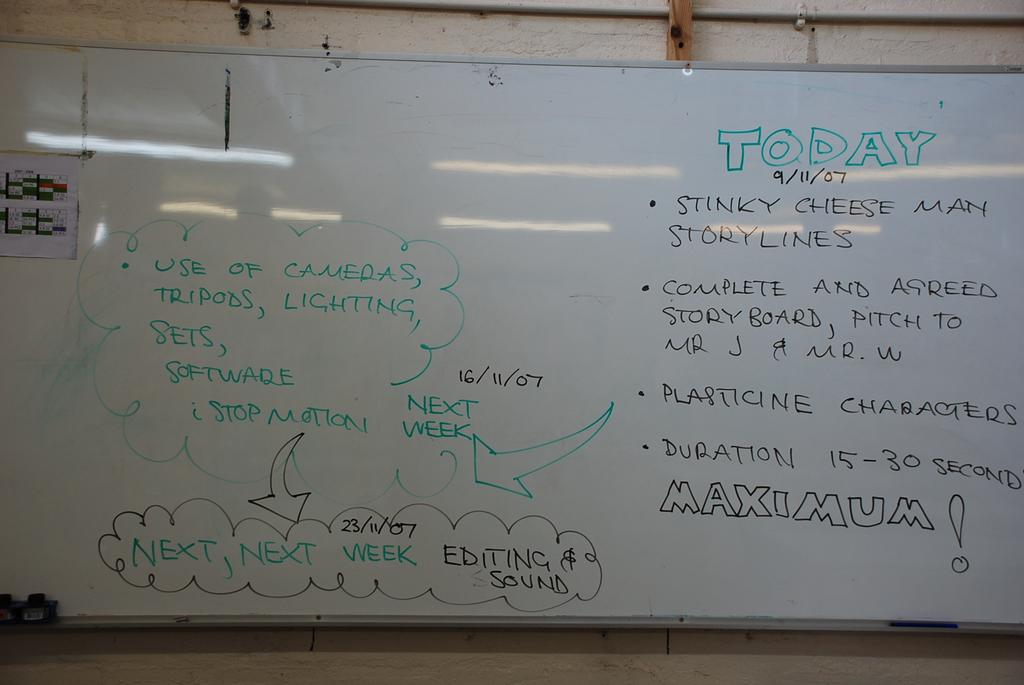Provide a one-sentence caption for the provided image. A whiteboard with notes that include info on cameras, tripods, and lighting. 